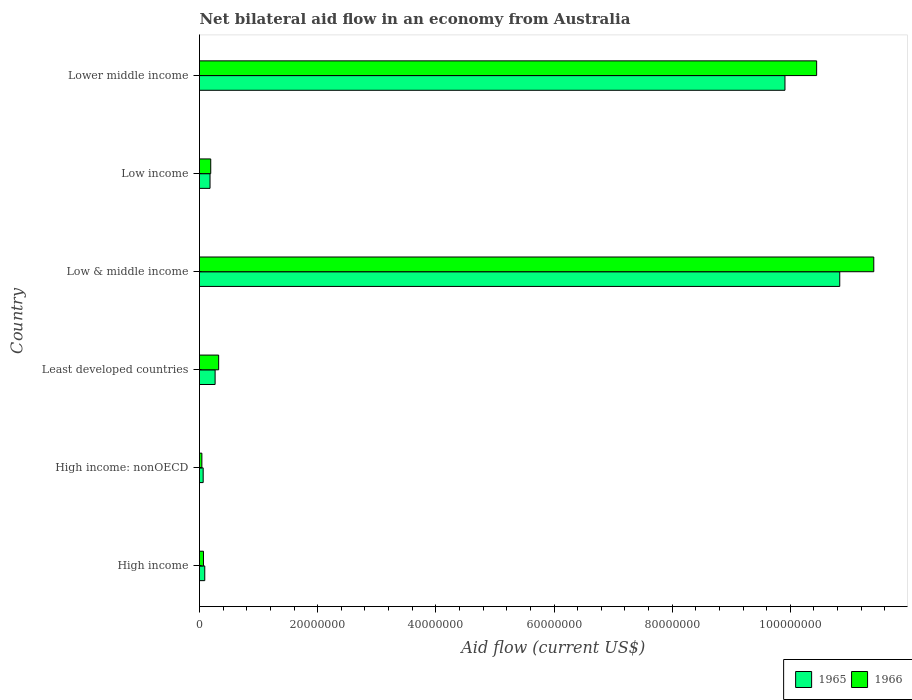How many different coloured bars are there?
Provide a short and direct response. 2. How many groups of bars are there?
Provide a succinct answer. 6. How many bars are there on the 1st tick from the top?
Make the answer very short. 2. How many bars are there on the 6th tick from the bottom?
Your response must be concise. 2. What is the label of the 3rd group of bars from the top?
Your answer should be compact. Low & middle income. In how many cases, is the number of bars for a given country not equal to the number of legend labels?
Your answer should be very brief. 0. What is the net bilateral aid flow in 1965 in High income?
Your answer should be very brief. 8.90e+05. Across all countries, what is the maximum net bilateral aid flow in 1965?
Provide a short and direct response. 1.08e+08. Across all countries, what is the minimum net bilateral aid flow in 1965?
Your answer should be very brief. 6.20e+05. In which country was the net bilateral aid flow in 1966 maximum?
Offer a terse response. Low & middle income. In which country was the net bilateral aid flow in 1965 minimum?
Give a very brief answer. High income: nonOECD. What is the total net bilateral aid flow in 1965 in the graph?
Provide a short and direct response. 2.13e+08. What is the difference between the net bilateral aid flow in 1965 in Least developed countries and that in Lower middle income?
Provide a succinct answer. -9.64e+07. What is the difference between the net bilateral aid flow in 1965 in Lower middle income and the net bilateral aid flow in 1966 in High income?
Your response must be concise. 9.84e+07. What is the average net bilateral aid flow in 1966 per country?
Offer a very short reply. 3.75e+07. What is the difference between the net bilateral aid flow in 1966 and net bilateral aid flow in 1965 in Low income?
Offer a terse response. 1.20e+05. What is the ratio of the net bilateral aid flow in 1965 in Low income to that in Lower middle income?
Your answer should be compact. 0.02. Is the net bilateral aid flow in 1966 in Low & middle income less than that in Lower middle income?
Give a very brief answer. No. What is the difference between the highest and the second highest net bilateral aid flow in 1965?
Provide a succinct answer. 9.27e+06. What is the difference between the highest and the lowest net bilateral aid flow in 1966?
Make the answer very short. 1.14e+08. What does the 2nd bar from the top in High income represents?
Make the answer very short. 1965. What does the 1st bar from the bottom in Low & middle income represents?
Provide a short and direct response. 1965. Are all the bars in the graph horizontal?
Make the answer very short. Yes. How many countries are there in the graph?
Your answer should be very brief. 6. What is the difference between two consecutive major ticks on the X-axis?
Your answer should be very brief. 2.00e+07. Does the graph contain any zero values?
Make the answer very short. No. Does the graph contain grids?
Offer a terse response. No. Where does the legend appear in the graph?
Provide a short and direct response. Bottom right. How many legend labels are there?
Ensure brevity in your answer.  2. What is the title of the graph?
Offer a terse response. Net bilateral aid flow in an economy from Australia. Does "1999" appear as one of the legend labels in the graph?
Your response must be concise. No. What is the label or title of the X-axis?
Make the answer very short. Aid flow (current US$). What is the Aid flow (current US$) in 1965 in High income?
Your response must be concise. 8.90e+05. What is the Aid flow (current US$) of 1966 in High income?
Offer a terse response. 6.70e+05. What is the Aid flow (current US$) in 1965 in High income: nonOECD?
Your answer should be very brief. 6.20e+05. What is the Aid flow (current US$) of 1966 in High income: nonOECD?
Ensure brevity in your answer.  4.00e+05. What is the Aid flow (current US$) in 1965 in Least developed countries?
Give a very brief answer. 2.64e+06. What is the Aid flow (current US$) in 1966 in Least developed countries?
Provide a succinct answer. 3.24e+06. What is the Aid flow (current US$) in 1965 in Low & middle income?
Give a very brief answer. 1.08e+08. What is the Aid flow (current US$) in 1966 in Low & middle income?
Offer a very short reply. 1.14e+08. What is the Aid flow (current US$) in 1965 in Low income?
Your response must be concise. 1.78e+06. What is the Aid flow (current US$) in 1966 in Low income?
Give a very brief answer. 1.90e+06. What is the Aid flow (current US$) of 1965 in Lower middle income?
Give a very brief answer. 9.91e+07. What is the Aid flow (current US$) of 1966 in Lower middle income?
Keep it short and to the point. 1.04e+08. Across all countries, what is the maximum Aid flow (current US$) in 1965?
Your response must be concise. 1.08e+08. Across all countries, what is the maximum Aid flow (current US$) in 1966?
Your answer should be compact. 1.14e+08. Across all countries, what is the minimum Aid flow (current US$) of 1965?
Give a very brief answer. 6.20e+05. What is the total Aid flow (current US$) in 1965 in the graph?
Provide a succinct answer. 2.13e+08. What is the total Aid flow (current US$) of 1966 in the graph?
Your response must be concise. 2.25e+08. What is the difference between the Aid flow (current US$) in 1965 in High income and that in High income: nonOECD?
Your answer should be very brief. 2.70e+05. What is the difference between the Aid flow (current US$) of 1965 in High income and that in Least developed countries?
Make the answer very short. -1.75e+06. What is the difference between the Aid flow (current US$) in 1966 in High income and that in Least developed countries?
Give a very brief answer. -2.57e+06. What is the difference between the Aid flow (current US$) of 1965 in High income and that in Low & middle income?
Your response must be concise. -1.07e+08. What is the difference between the Aid flow (current US$) of 1966 in High income and that in Low & middle income?
Your response must be concise. -1.13e+08. What is the difference between the Aid flow (current US$) in 1965 in High income and that in Low income?
Make the answer very short. -8.90e+05. What is the difference between the Aid flow (current US$) of 1966 in High income and that in Low income?
Your answer should be compact. -1.23e+06. What is the difference between the Aid flow (current US$) of 1965 in High income and that in Lower middle income?
Give a very brief answer. -9.82e+07. What is the difference between the Aid flow (current US$) of 1966 in High income and that in Lower middle income?
Your answer should be compact. -1.04e+08. What is the difference between the Aid flow (current US$) in 1965 in High income: nonOECD and that in Least developed countries?
Offer a very short reply. -2.02e+06. What is the difference between the Aid flow (current US$) of 1966 in High income: nonOECD and that in Least developed countries?
Your answer should be very brief. -2.84e+06. What is the difference between the Aid flow (current US$) of 1965 in High income: nonOECD and that in Low & middle income?
Ensure brevity in your answer.  -1.08e+08. What is the difference between the Aid flow (current US$) in 1966 in High income: nonOECD and that in Low & middle income?
Ensure brevity in your answer.  -1.14e+08. What is the difference between the Aid flow (current US$) of 1965 in High income: nonOECD and that in Low income?
Offer a very short reply. -1.16e+06. What is the difference between the Aid flow (current US$) of 1966 in High income: nonOECD and that in Low income?
Provide a succinct answer. -1.50e+06. What is the difference between the Aid flow (current US$) of 1965 in High income: nonOECD and that in Lower middle income?
Provide a succinct answer. -9.85e+07. What is the difference between the Aid flow (current US$) in 1966 in High income: nonOECD and that in Lower middle income?
Offer a terse response. -1.04e+08. What is the difference between the Aid flow (current US$) of 1965 in Least developed countries and that in Low & middle income?
Keep it short and to the point. -1.06e+08. What is the difference between the Aid flow (current US$) in 1966 in Least developed countries and that in Low & middle income?
Your answer should be compact. -1.11e+08. What is the difference between the Aid flow (current US$) of 1965 in Least developed countries and that in Low income?
Keep it short and to the point. 8.60e+05. What is the difference between the Aid flow (current US$) of 1966 in Least developed countries and that in Low income?
Make the answer very short. 1.34e+06. What is the difference between the Aid flow (current US$) in 1965 in Least developed countries and that in Lower middle income?
Your answer should be very brief. -9.64e+07. What is the difference between the Aid flow (current US$) in 1966 in Least developed countries and that in Lower middle income?
Provide a short and direct response. -1.01e+08. What is the difference between the Aid flow (current US$) in 1965 in Low & middle income and that in Low income?
Give a very brief answer. 1.07e+08. What is the difference between the Aid flow (current US$) in 1966 in Low & middle income and that in Low income?
Keep it short and to the point. 1.12e+08. What is the difference between the Aid flow (current US$) of 1965 in Low & middle income and that in Lower middle income?
Your response must be concise. 9.27e+06. What is the difference between the Aid flow (current US$) in 1966 in Low & middle income and that in Lower middle income?
Offer a terse response. 9.67e+06. What is the difference between the Aid flow (current US$) in 1965 in Low income and that in Lower middle income?
Offer a terse response. -9.73e+07. What is the difference between the Aid flow (current US$) of 1966 in Low income and that in Lower middle income?
Your response must be concise. -1.03e+08. What is the difference between the Aid flow (current US$) of 1965 in High income and the Aid flow (current US$) of 1966 in High income: nonOECD?
Make the answer very short. 4.90e+05. What is the difference between the Aid flow (current US$) of 1965 in High income and the Aid flow (current US$) of 1966 in Least developed countries?
Offer a very short reply. -2.35e+06. What is the difference between the Aid flow (current US$) in 1965 in High income and the Aid flow (current US$) in 1966 in Low & middle income?
Provide a short and direct response. -1.13e+08. What is the difference between the Aid flow (current US$) in 1965 in High income and the Aid flow (current US$) in 1966 in Low income?
Give a very brief answer. -1.01e+06. What is the difference between the Aid flow (current US$) in 1965 in High income and the Aid flow (current US$) in 1966 in Lower middle income?
Provide a succinct answer. -1.04e+08. What is the difference between the Aid flow (current US$) in 1965 in High income: nonOECD and the Aid flow (current US$) in 1966 in Least developed countries?
Offer a very short reply. -2.62e+06. What is the difference between the Aid flow (current US$) in 1965 in High income: nonOECD and the Aid flow (current US$) in 1966 in Low & middle income?
Keep it short and to the point. -1.14e+08. What is the difference between the Aid flow (current US$) in 1965 in High income: nonOECD and the Aid flow (current US$) in 1966 in Low income?
Provide a short and direct response. -1.28e+06. What is the difference between the Aid flow (current US$) in 1965 in High income: nonOECD and the Aid flow (current US$) in 1966 in Lower middle income?
Give a very brief answer. -1.04e+08. What is the difference between the Aid flow (current US$) in 1965 in Least developed countries and the Aid flow (current US$) in 1966 in Low & middle income?
Ensure brevity in your answer.  -1.11e+08. What is the difference between the Aid flow (current US$) of 1965 in Least developed countries and the Aid flow (current US$) of 1966 in Low income?
Your answer should be very brief. 7.40e+05. What is the difference between the Aid flow (current US$) of 1965 in Least developed countries and the Aid flow (current US$) of 1966 in Lower middle income?
Your answer should be very brief. -1.02e+08. What is the difference between the Aid flow (current US$) in 1965 in Low & middle income and the Aid flow (current US$) in 1966 in Low income?
Your answer should be compact. 1.06e+08. What is the difference between the Aid flow (current US$) of 1965 in Low & middle income and the Aid flow (current US$) of 1966 in Lower middle income?
Your answer should be compact. 3.91e+06. What is the difference between the Aid flow (current US$) in 1965 in Low income and the Aid flow (current US$) in 1966 in Lower middle income?
Your response must be concise. -1.03e+08. What is the average Aid flow (current US$) of 1965 per country?
Your response must be concise. 3.56e+07. What is the average Aid flow (current US$) of 1966 per country?
Give a very brief answer. 3.75e+07. What is the difference between the Aid flow (current US$) of 1965 and Aid flow (current US$) of 1966 in High income?
Provide a succinct answer. 2.20e+05. What is the difference between the Aid flow (current US$) of 1965 and Aid flow (current US$) of 1966 in High income: nonOECD?
Offer a very short reply. 2.20e+05. What is the difference between the Aid flow (current US$) of 1965 and Aid flow (current US$) of 1966 in Least developed countries?
Your answer should be compact. -6.00e+05. What is the difference between the Aid flow (current US$) of 1965 and Aid flow (current US$) of 1966 in Low & middle income?
Offer a very short reply. -5.76e+06. What is the difference between the Aid flow (current US$) in 1965 and Aid flow (current US$) in 1966 in Low income?
Your answer should be compact. -1.20e+05. What is the difference between the Aid flow (current US$) in 1965 and Aid flow (current US$) in 1966 in Lower middle income?
Provide a succinct answer. -5.36e+06. What is the ratio of the Aid flow (current US$) of 1965 in High income to that in High income: nonOECD?
Ensure brevity in your answer.  1.44. What is the ratio of the Aid flow (current US$) in 1966 in High income to that in High income: nonOECD?
Your response must be concise. 1.68. What is the ratio of the Aid flow (current US$) in 1965 in High income to that in Least developed countries?
Ensure brevity in your answer.  0.34. What is the ratio of the Aid flow (current US$) in 1966 in High income to that in Least developed countries?
Your response must be concise. 0.21. What is the ratio of the Aid flow (current US$) of 1965 in High income to that in Low & middle income?
Your answer should be very brief. 0.01. What is the ratio of the Aid flow (current US$) in 1966 in High income to that in Low & middle income?
Offer a very short reply. 0.01. What is the ratio of the Aid flow (current US$) of 1966 in High income to that in Low income?
Give a very brief answer. 0.35. What is the ratio of the Aid flow (current US$) of 1965 in High income to that in Lower middle income?
Your answer should be compact. 0.01. What is the ratio of the Aid flow (current US$) in 1966 in High income to that in Lower middle income?
Give a very brief answer. 0.01. What is the ratio of the Aid flow (current US$) in 1965 in High income: nonOECD to that in Least developed countries?
Your response must be concise. 0.23. What is the ratio of the Aid flow (current US$) in 1966 in High income: nonOECD to that in Least developed countries?
Your response must be concise. 0.12. What is the ratio of the Aid flow (current US$) of 1965 in High income: nonOECD to that in Low & middle income?
Provide a succinct answer. 0.01. What is the ratio of the Aid flow (current US$) of 1966 in High income: nonOECD to that in Low & middle income?
Make the answer very short. 0. What is the ratio of the Aid flow (current US$) in 1965 in High income: nonOECD to that in Low income?
Provide a short and direct response. 0.35. What is the ratio of the Aid flow (current US$) in 1966 in High income: nonOECD to that in Low income?
Your answer should be compact. 0.21. What is the ratio of the Aid flow (current US$) of 1965 in High income: nonOECD to that in Lower middle income?
Make the answer very short. 0.01. What is the ratio of the Aid flow (current US$) of 1966 in High income: nonOECD to that in Lower middle income?
Keep it short and to the point. 0. What is the ratio of the Aid flow (current US$) in 1965 in Least developed countries to that in Low & middle income?
Ensure brevity in your answer.  0.02. What is the ratio of the Aid flow (current US$) in 1966 in Least developed countries to that in Low & middle income?
Offer a terse response. 0.03. What is the ratio of the Aid flow (current US$) of 1965 in Least developed countries to that in Low income?
Your answer should be compact. 1.48. What is the ratio of the Aid flow (current US$) in 1966 in Least developed countries to that in Low income?
Provide a short and direct response. 1.71. What is the ratio of the Aid flow (current US$) of 1965 in Least developed countries to that in Lower middle income?
Offer a terse response. 0.03. What is the ratio of the Aid flow (current US$) in 1966 in Least developed countries to that in Lower middle income?
Make the answer very short. 0.03. What is the ratio of the Aid flow (current US$) of 1965 in Low & middle income to that in Low income?
Your answer should be very brief. 60.88. What is the ratio of the Aid flow (current US$) in 1966 in Low & middle income to that in Low income?
Give a very brief answer. 60.06. What is the ratio of the Aid flow (current US$) of 1965 in Low & middle income to that in Lower middle income?
Offer a terse response. 1.09. What is the ratio of the Aid flow (current US$) in 1966 in Low & middle income to that in Lower middle income?
Give a very brief answer. 1.09. What is the ratio of the Aid flow (current US$) in 1965 in Low income to that in Lower middle income?
Provide a short and direct response. 0.02. What is the ratio of the Aid flow (current US$) of 1966 in Low income to that in Lower middle income?
Offer a terse response. 0.02. What is the difference between the highest and the second highest Aid flow (current US$) in 1965?
Offer a very short reply. 9.27e+06. What is the difference between the highest and the second highest Aid flow (current US$) of 1966?
Offer a very short reply. 9.67e+06. What is the difference between the highest and the lowest Aid flow (current US$) of 1965?
Provide a short and direct response. 1.08e+08. What is the difference between the highest and the lowest Aid flow (current US$) in 1966?
Provide a short and direct response. 1.14e+08. 